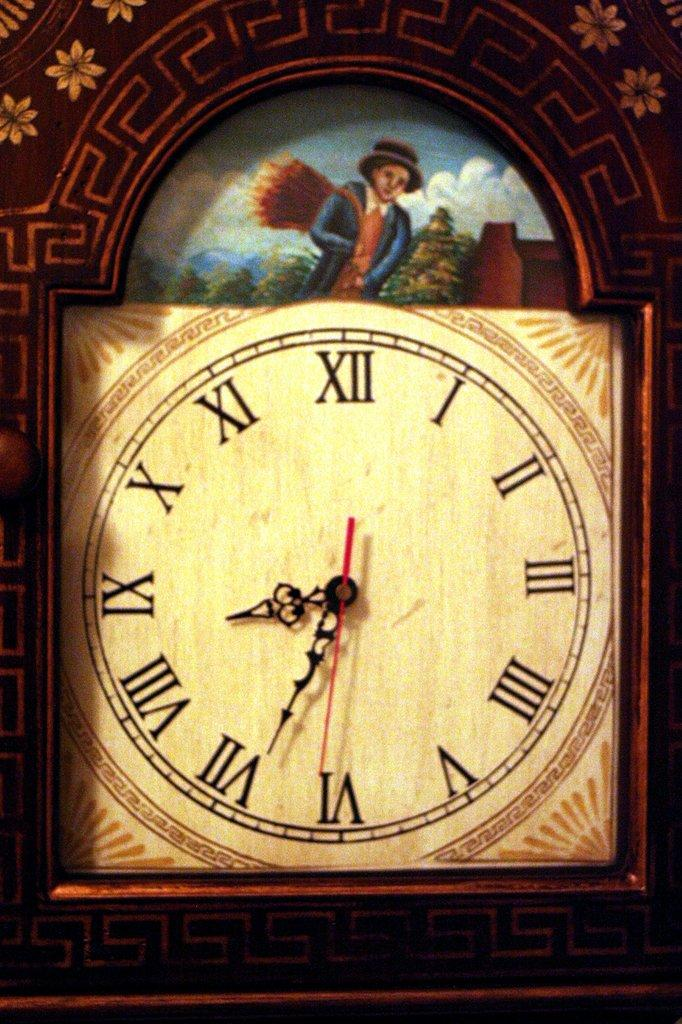<image>
Summarize the visual content of the image. An antique clock with a young boy in it shows the time as 8:35 